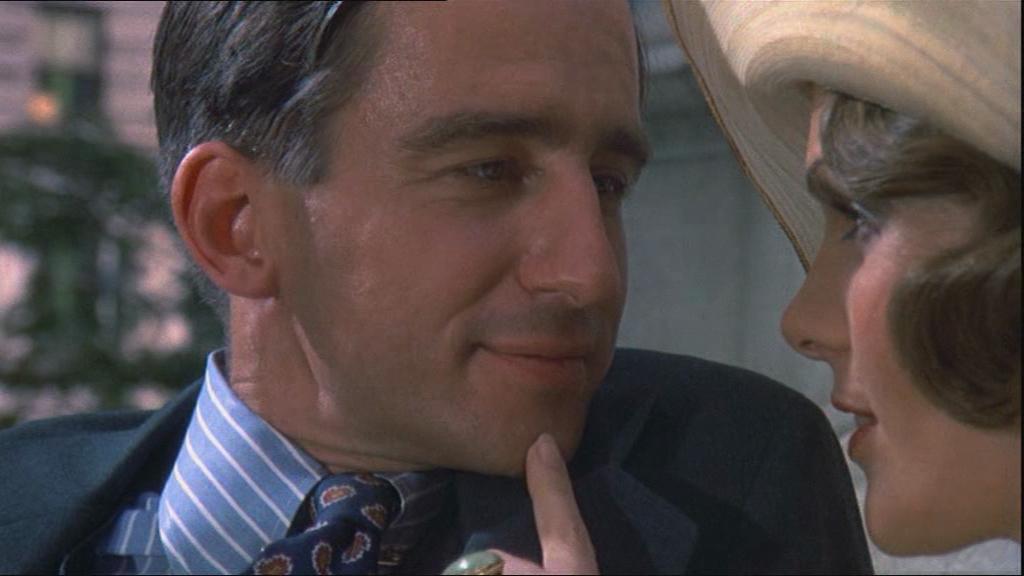How would you summarize this image in a sentence or two? In this image the foreground I can see two people and a person on the right side wearing a cap and the background is blurry 